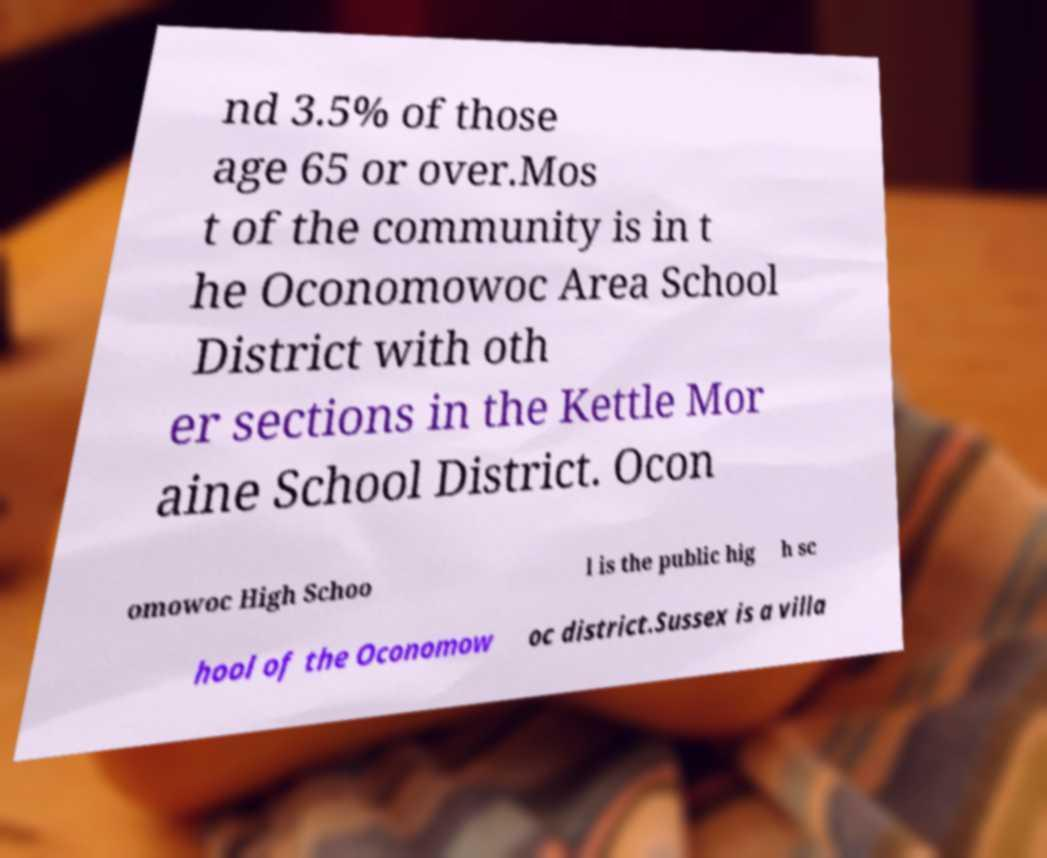There's text embedded in this image that I need extracted. Can you transcribe it verbatim? nd 3.5% of those age 65 or over.Mos t of the community is in t he Oconomowoc Area School District with oth er sections in the Kettle Mor aine School District. Ocon omowoc High Schoo l is the public hig h sc hool of the Oconomow oc district.Sussex is a villa 